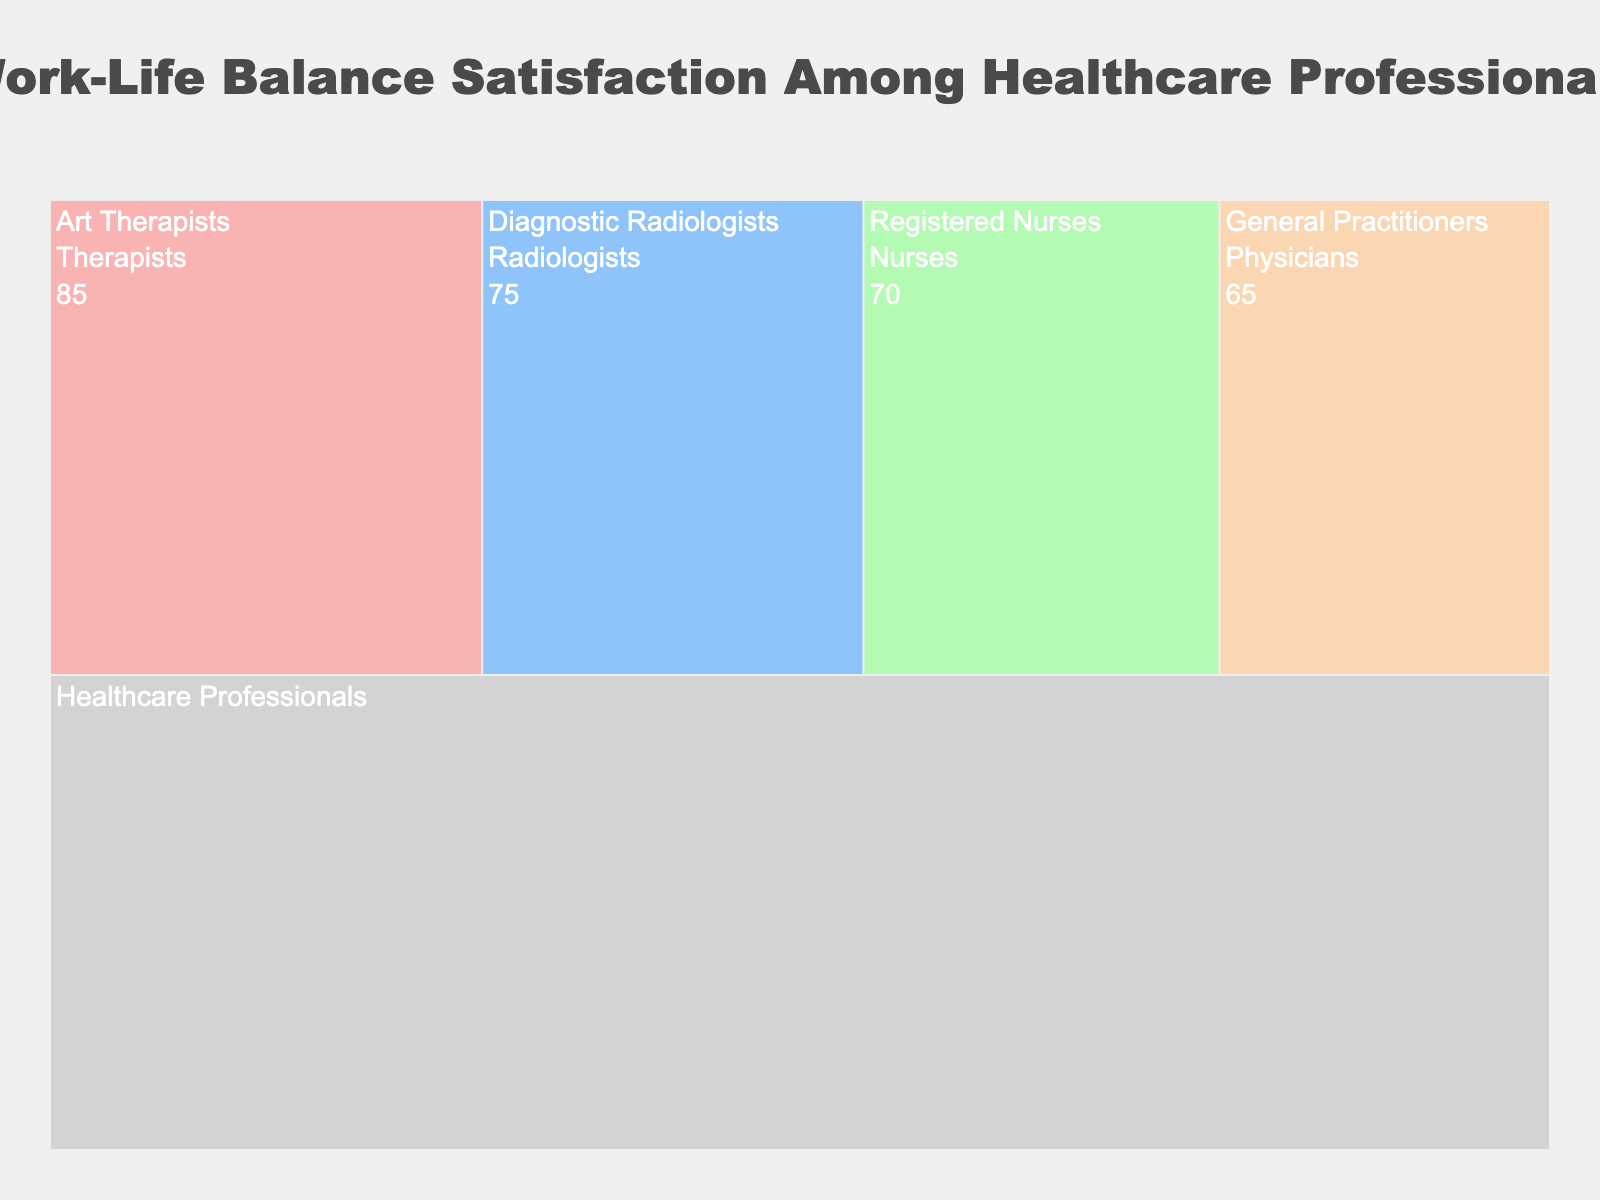How many groups of healthcare professionals are illustrated in the chart? First, identify all the distinct groups in the chart: Art Therapists, Diagnostic Radiologists, Registered Nurses, General Practitioners. Count these groups.
Answer: 4 Which professional group shows the highest satisfaction level in work-life balance? Locate the satisfaction levels associated with each professional group. The Art Therapists have the highest value at 85%.
Answer: Art Therapists What's the combined satisfaction level for Nurses and Physicians? Identify the satisfaction levels of Registered Nurses (70%) and General Practitioners (65%). Sum these values: 70 + 65 = 135.
Answer: 135 How much higher is the satisfaction level of Art Therapists compared to Diagnostic Radiologists? Subtract the satisfaction level of Diagnostic Radiologists (75%) from that of Art Therapists (85%). 85 - 75 = 10.
Answer: 10 Which category has the lowest satisfaction level? Compare the satisfaction levels of all professional groups. General Practitioners have the lowest at 65%.
Answer: General Practitioners What is the average satisfaction level of all groups shown? To find the average, sum the satisfaction levels of all groups: 85 + 75 + 70 + 65 = 295. Then, divide by the number of groups (4): 295 / 4 = 73.75.
Answer: 73.75 Are the satisfaction levels of Nurses closer to Radiologists or Physicians? Calculate the differences: Nurses (70) and Radiologists (75) is 5, Nurses and Physicians (65) is also 5. The distances are equal.
Answer: Equally close How is the title of the chart related to the visual information presented? The title "Work-Life Balance Satisfaction Among Healthcare Professionals" summarizes the focus of the chart, which displays satisfaction levels for different healthcare professional groups.
Answer: Summarizes the chart's focus In the context of the chart, which group might you want to discuss work-life balance strategies with, based on satisfaction levels? General Practitioners have the lowest satisfaction level at 65%, indicating they might benefit the most from discussing work-life balance strategies.
Answer: General Practitioners How does the visual structure of the Icicle Chart help in interpreting the distribution of satisfaction levels? The hierarchical structure and color variations of the Icicle Chart effectively illustrate how satisfaction levels differ among groups, making it easier to visually compare both the hierarchy and individual values.
Answer: Hierarchical and comparative 